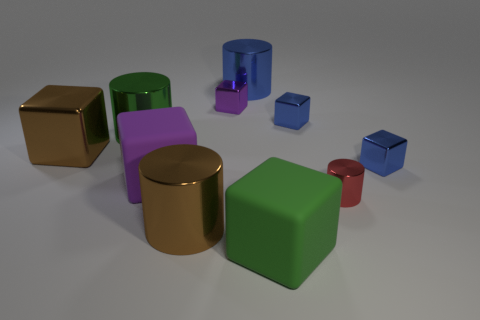Subtract all large shiny cubes. How many cubes are left? 5 Subtract all brown cubes. How many cubes are left? 5 Subtract 1 cubes. How many cubes are left? 5 Subtract all yellow blocks. Subtract all yellow cylinders. How many blocks are left? 6 Subtract all cubes. How many objects are left? 4 Subtract all green shiny things. Subtract all small blue shiny objects. How many objects are left? 7 Add 8 large brown cylinders. How many large brown cylinders are left? 9 Add 9 small red matte blocks. How many small red matte blocks exist? 9 Subtract 0 green spheres. How many objects are left? 10 